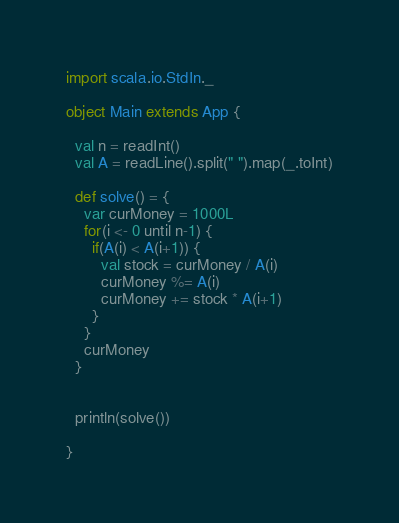Convert code to text. <code><loc_0><loc_0><loc_500><loc_500><_Scala_>import scala.io.StdIn._

object Main extends App {

  val n = readInt()
  val A = readLine().split(" ").map(_.toInt)

  def solve() = {
    var curMoney = 1000L
    for(i <- 0 until n-1) {
      if(A(i) < A(i+1)) {
        val stock = curMoney / A(i)
        curMoney %= A(i)
        curMoney += stock * A(i+1)
      }
    }
    curMoney
  }


  println(solve())

}

</code> 